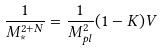<formula> <loc_0><loc_0><loc_500><loc_500>\frac { 1 } { M _ { \ast } ^ { 2 + N } } = \frac { 1 } { M _ { p l } ^ { 2 } } ( 1 - K ) V</formula> 